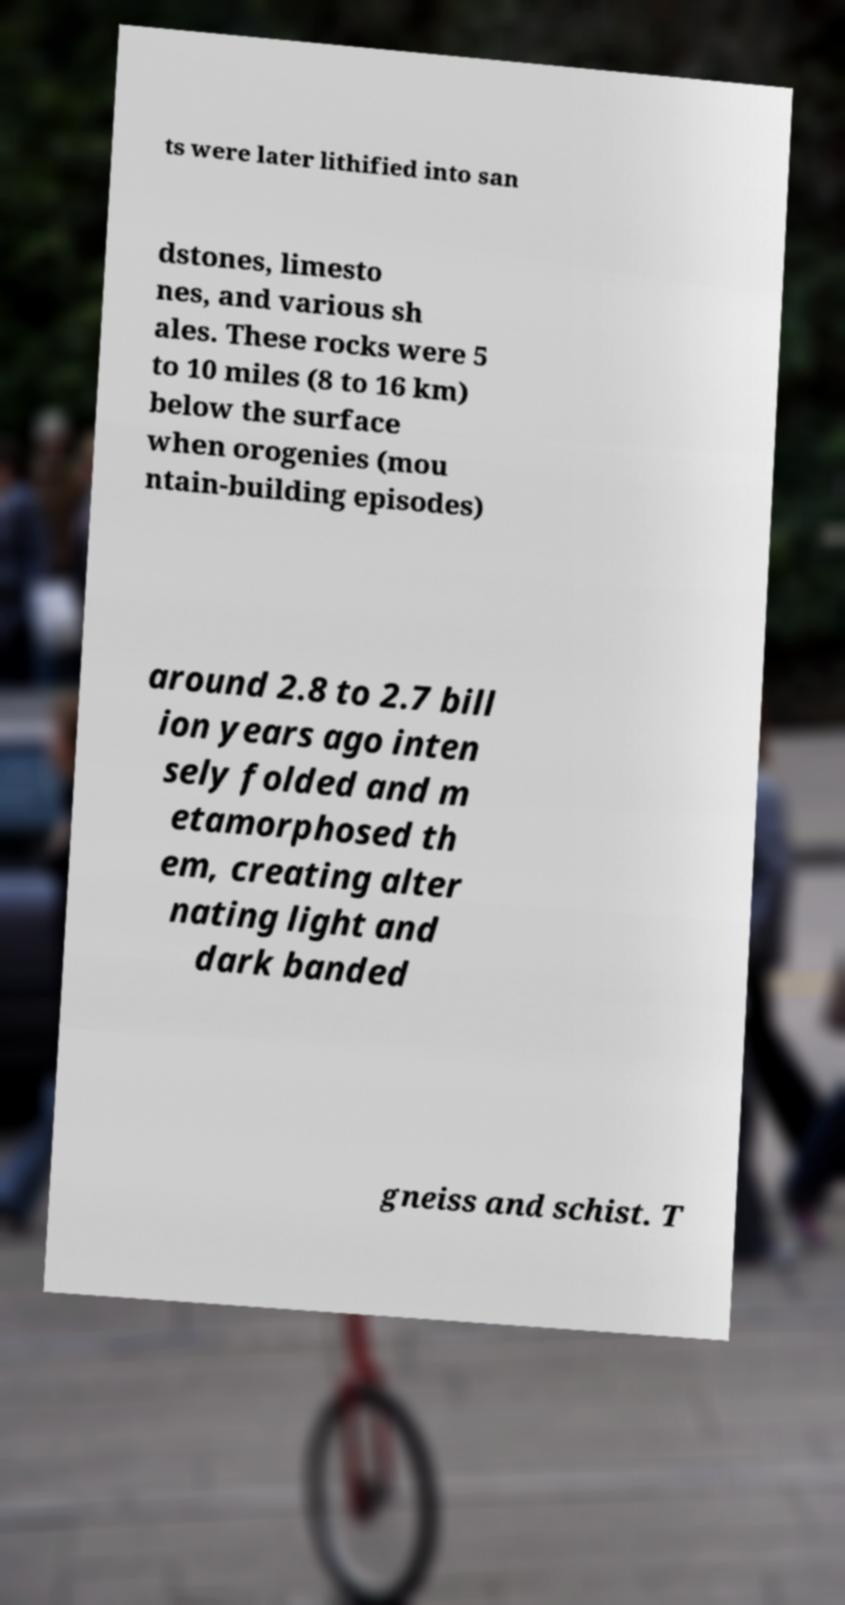I need the written content from this picture converted into text. Can you do that? ts were later lithified into san dstones, limesto nes, and various sh ales. These rocks were 5 to 10 miles (8 to 16 km) below the surface when orogenies (mou ntain-building episodes) around 2.8 to 2.7 bill ion years ago inten sely folded and m etamorphosed th em, creating alter nating light and dark banded gneiss and schist. T 